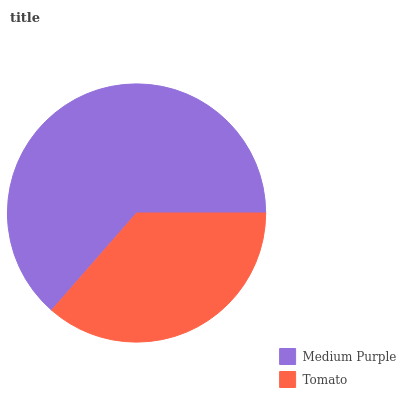Is Tomato the minimum?
Answer yes or no. Yes. Is Medium Purple the maximum?
Answer yes or no. Yes. Is Tomato the maximum?
Answer yes or no. No. Is Medium Purple greater than Tomato?
Answer yes or no. Yes. Is Tomato less than Medium Purple?
Answer yes or no. Yes. Is Tomato greater than Medium Purple?
Answer yes or no. No. Is Medium Purple less than Tomato?
Answer yes or no. No. Is Medium Purple the high median?
Answer yes or no. Yes. Is Tomato the low median?
Answer yes or no. Yes. Is Tomato the high median?
Answer yes or no. No. Is Medium Purple the low median?
Answer yes or no. No. 